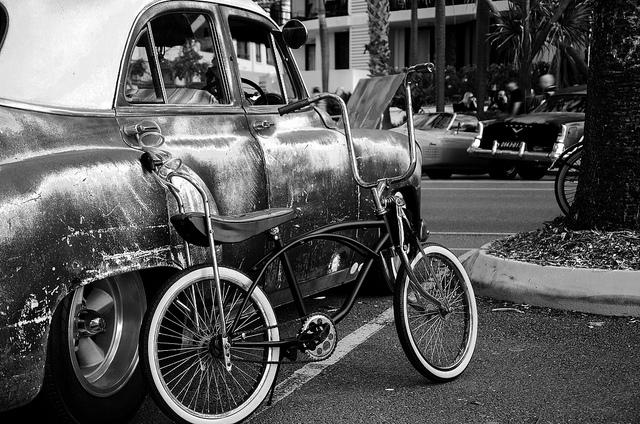Is the image in black and white?
Concise answer only. Yes. How many bicycles are in the photo?
Short answer required. 2. Is the car in the forefront a new car?
Quick response, please. No. How many bikes are on the car?
Short answer required. 1. Where is the bicycle?
Answer briefly. Next to car. What vehicle is this?
Short answer required. Car. What is shown in the mirror?
Give a very brief answer. Car. 